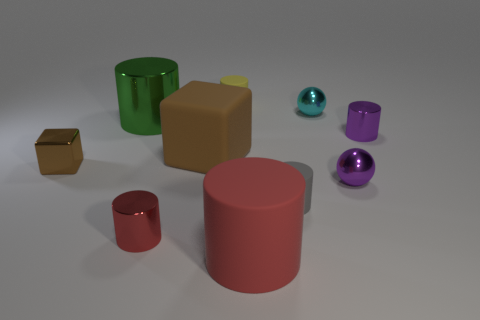Is the small gray thing the same shape as the red matte object?
Ensure brevity in your answer.  Yes. Is there anything else that is the same size as the brown matte thing?
Keep it short and to the point. Yes. What is the size of the purple metal thing that is the same shape as the cyan shiny object?
Offer a terse response. Small. Is the number of tiny spheres that are in front of the large red rubber object greater than the number of purple spheres that are in front of the brown rubber cube?
Offer a very short reply. No. Is the large cube made of the same material as the brown block in front of the large brown cube?
Provide a short and direct response. No. Is there any other thing that is the same shape as the brown shiny object?
Your answer should be very brief. Yes. What color is the small cylinder that is both left of the gray rubber thing and in front of the tiny cyan shiny sphere?
Offer a terse response. Red. The matte object behind the tiny cyan shiny thing has what shape?
Provide a succinct answer. Cylinder. There is a gray object that is to the right of the red cylinder behind the rubber cylinder in front of the gray rubber thing; how big is it?
Your answer should be compact. Small. How many matte objects are to the right of the shiny object behind the green cylinder?
Your answer should be compact. 0. 